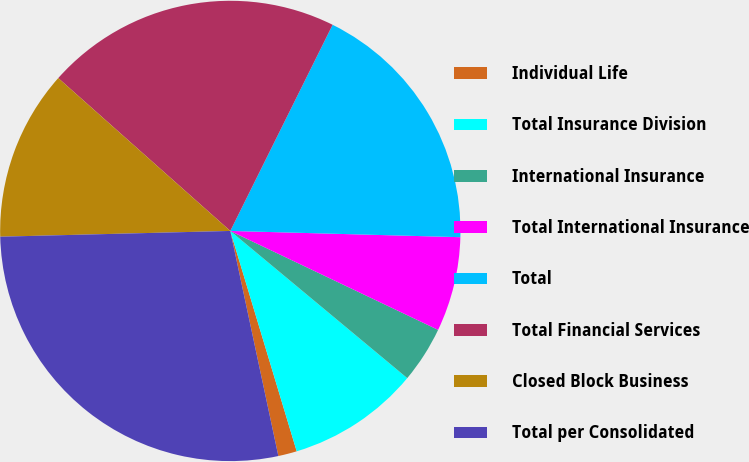Convert chart. <chart><loc_0><loc_0><loc_500><loc_500><pie_chart><fcel>Individual Life<fcel>Total Insurance Division<fcel>International Insurance<fcel>Total International Insurance<fcel>Total<fcel>Total Financial Services<fcel>Closed Block Business<fcel>Total per Consolidated<nl><fcel>1.31%<fcel>9.3%<fcel>3.97%<fcel>6.64%<fcel>18.1%<fcel>20.77%<fcel>11.96%<fcel>27.95%<nl></chart> 